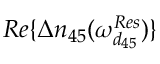<formula> <loc_0><loc_0><loc_500><loc_500>R e \{ \Delta n _ { 4 5 } ( \omega _ { d _ { 4 5 } } ^ { R e s } ) \}</formula> 